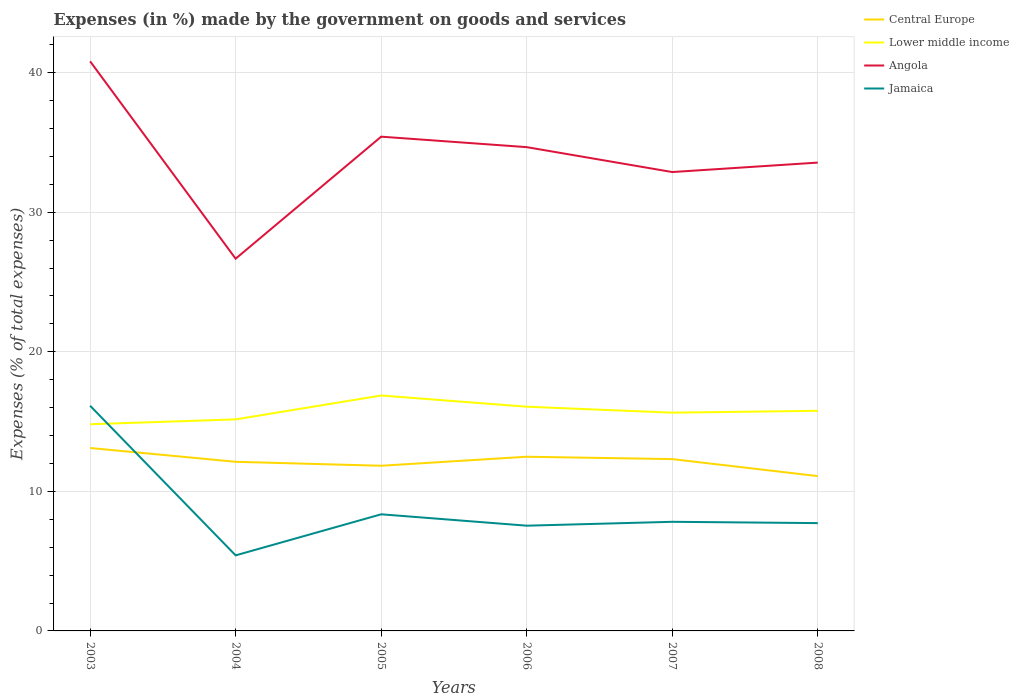Is the number of lines equal to the number of legend labels?
Provide a succinct answer. Yes. Across all years, what is the maximum percentage of expenses made by the government on goods and services in Jamaica?
Provide a succinct answer. 5.41. In which year was the percentage of expenses made by the government on goods and services in Angola maximum?
Your answer should be compact. 2004. What is the total percentage of expenses made by the government on goods and services in Central Europe in the graph?
Your answer should be compact. 1.39. What is the difference between the highest and the second highest percentage of expenses made by the government on goods and services in Lower middle income?
Ensure brevity in your answer.  2.06. How many lines are there?
Keep it short and to the point. 4. How many years are there in the graph?
Give a very brief answer. 6. Are the values on the major ticks of Y-axis written in scientific E-notation?
Make the answer very short. No. How are the legend labels stacked?
Make the answer very short. Vertical. What is the title of the graph?
Offer a very short reply. Expenses (in %) made by the government on goods and services. What is the label or title of the X-axis?
Give a very brief answer. Years. What is the label or title of the Y-axis?
Provide a short and direct response. Expenses (% of total expenses). What is the Expenses (% of total expenses) of Central Europe in 2003?
Keep it short and to the point. 13.11. What is the Expenses (% of total expenses) in Lower middle income in 2003?
Your answer should be compact. 14.81. What is the Expenses (% of total expenses) of Angola in 2003?
Ensure brevity in your answer.  40.81. What is the Expenses (% of total expenses) in Jamaica in 2003?
Offer a very short reply. 16.14. What is the Expenses (% of total expenses) of Central Europe in 2004?
Keep it short and to the point. 12.12. What is the Expenses (% of total expenses) in Lower middle income in 2004?
Provide a succinct answer. 15.16. What is the Expenses (% of total expenses) in Angola in 2004?
Offer a terse response. 26.67. What is the Expenses (% of total expenses) in Jamaica in 2004?
Keep it short and to the point. 5.41. What is the Expenses (% of total expenses) of Central Europe in 2005?
Ensure brevity in your answer.  11.83. What is the Expenses (% of total expenses) in Lower middle income in 2005?
Ensure brevity in your answer.  16.87. What is the Expenses (% of total expenses) of Angola in 2005?
Your answer should be very brief. 35.41. What is the Expenses (% of total expenses) of Jamaica in 2005?
Provide a short and direct response. 8.36. What is the Expenses (% of total expenses) in Central Europe in 2006?
Offer a very short reply. 12.48. What is the Expenses (% of total expenses) in Lower middle income in 2006?
Provide a short and direct response. 16.07. What is the Expenses (% of total expenses) in Angola in 2006?
Keep it short and to the point. 34.66. What is the Expenses (% of total expenses) of Jamaica in 2006?
Your answer should be very brief. 7.54. What is the Expenses (% of total expenses) of Central Europe in 2007?
Give a very brief answer. 12.31. What is the Expenses (% of total expenses) of Lower middle income in 2007?
Your answer should be very brief. 15.64. What is the Expenses (% of total expenses) in Angola in 2007?
Provide a short and direct response. 32.88. What is the Expenses (% of total expenses) of Jamaica in 2007?
Provide a succinct answer. 7.82. What is the Expenses (% of total expenses) of Central Europe in 2008?
Your answer should be very brief. 11.09. What is the Expenses (% of total expenses) in Lower middle income in 2008?
Make the answer very short. 15.77. What is the Expenses (% of total expenses) in Angola in 2008?
Ensure brevity in your answer.  33.56. What is the Expenses (% of total expenses) in Jamaica in 2008?
Offer a very short reply. 7.72. Across all years, what is the maximum Expenses (% of total expenses) of Central Europe?
Ensure brevity in your answer.  13.11. Across all years, what is the maximum Expenses (% of total expenses) of Lower middle income?
Give a very brief answer. 16.87. Across all years, what is the maximum Expenses (% of total expenses) of Angola?
Your answer should be very brief. 40.81. Across all years, what is the maximum Expenses (% of total expenses) of Jamaica?
Make the answer very short. 16.14. Across all years, what is the minimum Expenses (% of total expenses) in Central Europe?
Make the answer very short. 11.09. Across all years, what is the minimum Expenses (% of total expenses) in Lower middle income?
Offer a terse response. 14.81. Across all years, what is the minimum Expenses (% of total expenses) in Angola?
Your response must be concise. 26.67. Across all years, what is the minimum Expenses (% of total expenses) of Jamaica?
Make the answer very short. 5.41. What is the total Expenses (% of total expenses) in Central Europe in the graph?
Keep it short and to the point. 72.94. What is the total Expenses (% of total expenses) in Lower middle income in the graph?
Ensure brevity in your answer.  94.31. What is the total Expenses (% of total expenses) in Angola in the graph?
Provide a succinct answer. 203.99. What is the total Expenses (% of total expenses) of Jamaica in the graph?
Your response must be concise. 52.99. What is the difference between the Expenses (% of total expenses) in Lower middle income in 2003 and that in 2004?
Offer a terse response. -0.35. What is the difference between the Expenses (% of total expenses) of Angola in 2003 and that in 2004?
Your answer should be compact. 14.14. What is the difference between the Expenses (% of total expenses) in Jamaica in 2003 and that in 2004?
Your answer should be very brief. 10.72. What is the difference between the Expenses (% of total expenses) in Central Europe in 2003 and that in 2005?
Keep it short and to the point. 1.27. What is the difference between the Expenses (% of total expenses) in Lower middle income in 2003 and that in 2005?
Your answer should be compact. -2.06. What is the difference between the Expenses (% of total expenses) of Angola in 2003 and that in 2005?
Provide a succinct answer. 5.4. What is the difference between the Expenses (% of total expenses) in Jamaica in 2003 and that in 2005?
Your answer should be compact. 7.78. What is the difference between the Expenses (% of total expenses) of Central Europe in 2003 and that in 2006?
Make the answer very short. 0.63. What is the difference between the Expenses (% of total expenses) of Lower middle income in 2003 and that in 2006?
Your answer should be very brief. -1.26. What is the difference between the Expenses (% of total expenses) of Angola in 2003 and that in 2006?
Your response must be concise. 6.15. What is the difference between the Expenses (% of total expenses) of Jamaica in 2003 and that in 2006?
Your answer should be very brief. 8.59. What is the difference between the Expenses (% of total expenses) in Central Europe in 2003 and that in 2007?
Make the answer very short. 0.8. What is the difference between the Expenses (% of total expenses) in Lower middle income in 2003 and that in 2007?
Ensure brevity in your answer.  -0.83. What is the difference between the Expenses (% of total expenses) in Angola in 2003 and that in 2007?
Offer a terse response. 7.94. What is the difference between the Expenses (% of total expenses) in Jamaica in 2003 and that in 2007?
Keep it short and to the point. 8.32. What is the difference between the Expenses (% of total expenses) of Central Europe in 2003 and that in 2008?
Give a very brief answer. 2.01. What is the difference between the Expenses (% of total expenses) in Lower middle income in 2003 and that in 2008?
Provide a succinct answer. -0.96. What is the difference between the Expenses (% of total expenses) in Angola in 2003 and that in 2008?
Give a very brief answer. 7.26. What is the difference between the Expenses (% of total expenses) in Jamaica in 2003 and that in 2008?
Provide a short and direct response. 8.41. What is the difference between the Expenses (% of total expenses) in Central Europe in 2004 and that in 2005?
Provide a succinct answer. 0.28. What is the difference between the Expenses (% of total expenses) of Lower middle income in 2004 and that in 2005?
Your response must be concise. -1.71. What is the difference between the Expenses (% of total expenses) in Angola in 2004 and that in 2005?
Provide a succinct answer. -8.74. What is the difference between the Expenses (% of total expenses) in Jamaica in 2004 and that in 2005?
Your answer should be compact. -2.94. What is the difference between the Expenses (% of total expenses) in Central Europe in 2004 and that in 2006?
Provide a succinct answer. -0.36. What is the difference between the Expenses (% of total expenses) of Lower middle income in 2004 and that in 2006?
Make the answer very short. -0.91. What is the difference between the Expenses (% of total expenses) in Angola in 2004 and that in 2006?
Make the answer very short. -7.99. What is the difference between the Expenses (% of total expenses) in Jamaica in 2004 and that in 2006?
Keep it short and to the point. -2.13. What is the difference between the Expenses (% of total expenses) in Central Europe in 2004 and that in 2007?
Your answer should be compact. -0.19. What is the difference between the Expenses (% of total expenses) of Lower middle income in 2004 and that in 2007?
Provide a short and direct response. -0.48. What is the difference between the Expenses (% of total expenses) of Angola in 2004 and that in 2007?
Make the answer very short. -6.21. What is the difference between the Expenses (% of total expenses) in Jamaica in 2004 and that in 2007?
Provide a short and direct response. -2.4. What is the difference between the Expenses (% of total expenses) of Central Europe in 2004 and that in 2008?
Make the answer very short. 1.03. What is the difference between the Expenses (% of total expenses) of Lower middle income in 2004 and that in 2008?
Make the answer very short. -0.61. What is the difference between the Expenses (% of total expenses) in Angola in 2004 and that in 2008?
Provide a short and direct response. -6.88. What is the difference between the Expenses (% of total expenses) in Jamaica in 2004 and that in 2008?
Provide a succinct answer. -2.31. What is the difference between the Expenses (% of total expenses) in Central Europe in 2005 and that in 2006?
Your response must be concise. -0.65. What is the difference between the Expenses (% of total expenses) of Lower middle income in 2005 and that in 2006?
Ensure brevity in your answer.  0.8. What is the difference between the Expenses (% of total expenses) in Angola in 2005 and that in 2006?
Make the answer very short. 0.75. What is the difference between the Expenses (% of total expenses) of Jamaica in 2005 and that in 2006?
Your answer should be very brief. 0.82. What is the difference between the Expenses (% of total expenses) of Central Europe in 2005 and that in 2007?
Give a very brief answer. -0.48. What is the difference between the Expenses (% of total expenses) of Lower middle income in 2005 and that in 2007?
Provide a succinct answer. 1.23. What is the difference between the Expenses (% of total expenses) in Angola in 2005 and that in 2007?
Provide a succinct answer. 2.54. What is the difference between the Expenses (% of total expenses) in Jamaica in 2005 and that in 2007?
Keep it short and to the point. 0.54. What is the difference between the Expenses (% of total expenses) in Central Europe in 2005 and that in 2008?
Provide a short and direct response. 0.74. What is the difference between the Expenses (% of total expenses) of Lower middle income in 2005 and that in 2008?
Give a very brief answer. 1.1. What is the difference between the Expenses (% of total expenses) in Angola in 2005 and that in 2008?
Provide a short and direct response. 1.86. What is the difference between the Expenses (% of total expenses) of Jamaica in 2005 and that in 2008?
Provide a short and direct response. 0.63. What is the difference between the Expenses (% of total expenses) of Central Europe in 2006 and that in 2007?
Give a very brief answer. 0.17. What is the difference between the Expenses (% of total expenses) in Lower middle income in 2006 and that in 2007?
Offer a very short reply. 0.43. What is the difference between the Expenses (% of total expenses) in Angola in 2006 and that in 2007?
Make the answer very short. 1.78. What is the difference between the Expenses (% of total expenses) of Jamaica in 2006 and that in 2007?
Keep it short and to the point. -0.28. What is the difference between the Expenses (% of total expenses) in Central Europe in 2006 and that in 2008?
Ensure brevity in your answer.  1.39. What is the difference between the Expenses (% of total expenses) of Lower middle income in 2006 and that in 2008?
Your response must be concise. 0.29. What is the difference between the Expenses (% of total expenses) in Angola in 2006 and that in 2008?
Provide a short and direct response. 1.11. What is the difference between the Expenses (% of total expenses) in Jamaica in 2006 and that in 2008?
Offer a very short reply. -0.18. What is the difference between the Expenses (% of total expenses) in Central Europe in 2007 and that in 2008?
Make the answer very short. 1.22. What is the difference between the Expenses (% of total expenses) in Lower middle income in 2007 and that in 2008?
Ensure brevity in your answer.  -0.13. What is the difference between the Expenses (% of total expenses) of Angola in 2007 and that in 2008?
Ensure brevity in your answer.  -0.68. What is the difference between the Expenses (% of total expenses) in Jamaica in 2007 and that in 2008?
Make the answer very short. 0.09. What is the difference between the Expenses (% of total expenses) in Central Europe in 2003 and the Expenses (% of total expenses) in Lower middle income in 2004?
Ensure brevity in your answer.  -2.05. What is the difference between the Expenses (% of total expenses) in Central Europe in 2003 and the Expenses (% of total expenses) in Angola in 2004?
Provide a succinct answer. -13.56. What is the difference between the Expenses (% of total expenses) of Central Europe in 2003 and the Expenses (% of total expenses) of Jamaica in 2004?
Your answer should be very brief. 7.69. What is the difference between the Expenses (% of total expenses) of Lower middle income in 2003 and the Expenses (% of total expenses) of Angola in 2004?
Your answer should be compact. -11.86. What is the difference between the Expenses (% of total expenses) in Lower middle income in 2003 and the Expenses (% of total expenses) in Jamaica in 2004?
Provide a succinct answer. 9.39. What is the difference between the Expenses (% of total expenses) in Angola in 2003 and the Expenses (% of total expenses) in Jamaica in 2004?
Your answer should be compact. 35.4. What is the difference between the Expenses (% of total expenses) of Central Europe in 2003 and the Expenses (% of total expenses) of Lower middle income in 2005?
Ensure brevity in your answer.  -3.76. What is the difference between the Expenses (% of total expenses) in Central Europe in 2003 and the Expenses (% of total expenses) in Angola in 2005?
Give a very brief answer. -22.31. What is the difference between the Expenses (% of total expenses) in Central Europe in 2003 and the Expenses (% of total expenses) in Jamaica in 2005?
Ensure brevity in your answer.  4.75. What is the difference between the Expenses (% of total expenses) of Lower middle income in 2003 and the Expenses (% of total expenses) of Angola in 2005?
Make the answer very short. -20.6. What is the difference between the Expenses (% of total expenses) in Lower middle income in 2003 and the Expenses (% of total expenses) in Jamaica in 2005?
Provide a succinct answer. 6.45. What is the difference between the Expenses (% of total expenses) of Angola in 2003 and the Expenses (% of total expenses) of Jamaica in 2005?
Give a very brief answer. 32.46. What is the difference between the Expenses (% of total expenses) in Central Europe in 2003 and the Expenses (% of total expenses) in Lower middle income in 2006?
Ensure brevity in your answer.  -2.96. What is the difference between the Expenses (% of total expenses) of Central Europe in 2003 and the Expenses (% of total expenses) of Angola in 2006?
Provide a succinct answer. -21.56. What is the difference between the Expenses (% of total expenses) of Central Europe in 2003 and the Expenses (% of total expenses) of Jamaica in 2006?
Ensure brevity in your answer.  5.57. What is the difference between the Expenses (% of total expenses) of Lower middle income in 2003 and the Expenses (% of total expenses) of Angola in 2006?
Your answer should be compact. -19.85. What is the difference between the Expenses (% of total expenses) in Lower middle income in 2003 and the Expenses (% of total expenses) in Jamaica in 2006?
Provide a short and direct response. 7.27. What is the difference between the Expenses (% of total expenses) of Angola in 2003 and the Expenses (% of total expenses) of Jamaica in 2006?
Your answer should be very brief. 33.27. What is the difference between the Expenses (% of total expenses) in Central Europe in 2003 and the Expenses (% of total expenses) in Lower middle income in 2007?
Make the answer very short. -2.53. What is the difference between the Expenses (% of total expenses) in Central Europe in 2003 and the Expenses (% of total expenses) in Angola in 2007?
Offer a very short reply. -19.77. What is the difference between the Expenses (% of total expenses) of Central Europe in 2003 and the Expenses (% of total expenses) of Jamaica in 2007?
Your response must be concise. 5.29. What is the difference between the Expenses (% of total expenses) in Lower middle income in 2003 and the Expenses (% of total expenses) in Angola in 2007?
Provide a succinct answer. -18.07. What is the difference between the Expenses (% of total expenses) of Lower middle income in 2003 and the Expenses (% of total expenses) of Jamaica in 2007?
Your answer should be compact. 6.99. What is the difference between the Expenses (% of total expenses) of Angola in 2003 and the Expenses (% of total expenses) of Jamaica in 2007?
Offer a terse response. 33. What is the difference between the Expenses (% of total expenses) of Central Europe in 2003 and the Expenses (% of total expenses) of Lower middle income in 2008?
Ensure brevity in your answer.  -2.66. What is the difference between the Expenses (% of total expenses) of Central Europe in 2003 and the Expenses (% of total expenses) of Angola in 2008?
Make the answer very short. -20.45. What is the difference between the Expenses (% of total expenses) in Central Europe in 2003 and the Expenses (% of total expenses) in Jamaica in 2008?
Ensure brevity in your answer.  5.38. What is the difference between the Expenses (% of total expenses) of Lower middle income in 2003 and the Expenses (% of total expenses) of Angola in 2008?
Offer a terse response. -18.75. What is the difference between the Expenses (% of total expenses) of Lower middle income in 2003 and the Expenses (% of total expenses) of Jamaica in 2008?
Keep it short and to the point. 7.08. What is the difference between the Expenses (% of total expenses) in Angola in 2003 and the Expenses (% of total expenses) in Jamaica in 2008?
Your answer should be very brief. 33.09. What is the difference between the Expenses (% of total expenses) in Central Europe in 2004 and the Expenses (% of total expenses) in Lower middle income in 2005?
Provide a succinct answer. -4.75. What is the difference between the Expenses (% of total expenses) in Central Europe in 2004 and the Expenses (% of total expenses) in Angola in 2005?
Provide a short and direct response. -23.3. What is the difference between the Expenses (% of total expenses) in Central Europe in 2004 and the Expenses (% of total expenses) in Jamaica in 2005?
Offer a very short reply. 3.76. What is the difference between the Expenses (% of total expenses) in Lower middle income in 2004 and the Expenses (% of total expenses) in Angola in 2005?
Make the answer very short. -20.26. What is the difference between the Expenses (% of total expenses) of Lower middle income in 2004 and the Expenses (% of total expenses) of Jamaica in 2005?
Provide a short and direct response. 6.8. What is the difference between the Expenses (% of total expenses) in Angola in 2004 and the Expenses (% of total expenses) in Jamaica in 2005?
Provide a succinct answer. 18.31. What is the difference between the Expenses (% of total expenses) of Central Europe in 2004 and the Expenses (% of total expenses) of Lower middle income in 2006?
Your response must be concise. -3.95. What is the difference between the Expenses (% of total expenses) in Central Europe in 2004 and the Expenses (% of total expenses) in Angola in 2006?
Keep it short and to the point. -22.54. What is the difference between the Expenses (% of total expenses) of Central Europe in 2004 and the Expenses (% of total expenses) of Jamaica in 2006?
Your answer should be compact. 4.58. What is the difference between the Expenses (% of total expenses) of Lower middle income in 2004 and the Expenses (% of total expenses) of Angola in 2006?
Provide a succinct answer. -19.51. What is the difference between the Expenses (% of total expenses) in Lower middle income in 2004 and the Expenses (% of total expenses) in Jamaica in 2006?
Offer a very short reply. 7.62. What is the difference between the Expenses (% of total expenses) in Angola in 2004 and the Expenses (% of total expenses) in Jamaica in 2006?
Offer a terse response. 19.13. What is the difference between the Expenses (% of total expenses) of Central Europe in 2004 and the Expenses (% of total expenses) of Lower middle income in 2007?
Your answer should be compact. -3.52. What is the difference between the Expenses (% of total expenses) of Central Europe in 2004 and the Expenses (% of total expenses) of Angola in 2007?
Offer a terse response. -20.76. What is the difference between the Expenses (% of total expenses) in Central Europe in 2004 and the Expenses (% of total expenses) in Jamaica in 2007?
Give a very brief answer. 4.3. What is the difference between the Expenses (% of total expenses) of Lower middle income in 2004 and the Expenses (% of total expenses) of Angola in 2007?
Make the answer very short. -17.72. What is the difference between the Expenses (% of total expenses) in Lower middle income in 2004 and the Expenses (% of total expenses) in Jamaica in 2007?
Offer a terse response. 7.34. What is the difference between the Expenses (% of total expenses) in Angola in 2004 and the Expenses (% of total expenses) in Jamaica in 2007?
Give a very brief answer. 18.85. What is the difference between the Expenses (% of total expenses) in Central Europe in 2004 and the Expenses (% of total expenses) in Lower middle income in 2008?
Give a very brief answer. -3.65. What is the difference between the Expenses (% of total expenses) in Central Europe in 2004 and the Expenses (% of total expenses) in Angola in 2008?
Offer a very short reply. -21.44. What is the difference between the Expenses (% of total expenses) of Central Europe in 2004 and the Expenses (% of total expenses) of Jamaica in 2008?
Your answer should be very brief. 4.39. What is the difference between the Expenses (% of total expenses) of Lower middle income in 2004 and the Expenses (% of total expenses) of Angola in 2008?
Ensure brevity in your answer.  -18.4. What is the difference between the Expenses (% of total expenses) in Lower middle income in 2004 and the Expenses (% of total expenses) in Jamaica in 2008?
Make the answer very short. 7.43. What is the difference between the Expenses (% of total expenses) of Angola in 2004 and the Expenses (% of total expenses) of Jamaica in 2008?
Your response must be concise. 18.95. What is the difference between the Expenses (% of total expenses) of Central Europe in 2005 and the Expenses (% of total expenses) of Lower middle income in 2006?
Keep it short and to the point. -4.23. What is the difference between the Expenses (% of total expenses) of Central Europe in 2005 and the Expenses (% of total expenses) of Angola in 2006?
Provide a short and direct response. -22.83. What is the difference between the Expenses (% of total expenses) in Central Europe in 2005 and the Expenses (% of total expenses) in Jamaica in 2006?
Provide a succinct answer. 4.29. What is the difference between the Expenses (% of total expenses) of Lower middle income in 2005 and the Expenses (% of total expenses) of Angola in 2006?
Offer a very short reply. -17.79. What is the difference between the Expenses (% of total expenses) of Lower middle income in 2005 and the Expenses (% of total expenses) of Jamaica in 2006?
Your answer should be very brief. 9.33. What is the difference between the Expenses (% of total expenses) of Angola in 2005 and the Expenses (% of total expenses) of Jamaica in 2006?
Offer a very short reply. 27.87. What is the difference between the Expenses (% of total expenses) in Central Europe in 2005 and the Expenses (% of total expenses) in Lower middle income in 2007?
Provide a succinct answer. -3.8. What is the difference between the Expenses (% of total expenses) in Central Europe in 2005 and the Expenses (% of total expenses) in Angola in 2007?
Offer a terse response. -21.04. What is the difference between the Expenses (% of total expenses) of Central Europe in 2005 and the Expenses (% of total expenses) of Jamaica in 2007?
Keep it short and to the point. 4.02. What is the difference between the Expenses (% of total expenses) of Lower middle income in 2005 and the Expenses (% of total expenses) of Angola in 2007?
Ensure brevity in your answer.  -16.01. What is the difference between the Expenses (% of total expenses) in Lower middle income in 2005 and the Expenses (% of total expenses) in Jamaica in 2007?
Offer a terse response. 9.05. What is the difference between the Expenses (% of total expenses) of Angola in 2005 and the Expenses (% of total expenses) of Jamaica in 2007?
Your answer should be very brief. 27.6. What is the difference between the Expenses (% of total expenses) of Central Europe in 2005 and the Expenses (% of total expenses) of Lower middle income in 2008?
Give a very brief answer. -3.94. What is the difference between the Expenses (% of total expenses) in Central Europe in 2005 and the Expenses (% of total expenses) in Angola in 2008?
Keep it short and to the point. -21.72. What is the difference between the Expenses (% of total expenses) in Central Europe in 2005 and the Expenses (% of total expenses) in Jamaica in 2008?
Provide a succinct answer. 4.11. What is the difference between the Expenses (% of total expenses) of Lower middle income in 2005 and the Expenses (% of total expenses) of Angola in 2008?
Give a very brief answer. -16.69. What is the difference between the Expenses (% of total expenses) of Lower middle income in 2005 and the Expenses (% of total expenses) of Jamaica in 2008?
Provide a short and direct response. 9.14. What is the difference between the Expenses (% of total expenses) in Angola in 2005 and the Expenses (% of total expenses) in Jamaica in 2008?
Your answer should be compact. 27.69. What is the difference between the Expenses (% of total expenses) in Central Europe in 2006 and the Expenses (% of total expenses) in Lower middle income in 2007?
Offer a very short reply. -3.16. What is the difference between the Expenses (% of total expenses) of Central Europe in 2006 and the Expenses (% of total expenses) of Angola in 2007?
Ensure brevity in your answer.  -20.4. What is the difference between the Expenses (% of total expenses) in Central Europe in 2006 and the Expenses (% of total expenses) in Jamaica in 2007?
Keep it short and to the point. 4.66. What is the difference between the Expenses (% of total expenses) in Lower middle income in 2006 and the Expenses (% of total expenses) in Angola in 2007?
Keep it short and to the point. -16.81. What is the difference between the Expenses (% of total expenses) of Lower middle income in 2006 and the Expenses (% of total expenses) of Jamaica in 2007?
Ensure brevity in your answer.  8.25. What is the difference between the Expenses (% of total expenses) in Angola in 2006 and the Expenses (% of total expenses) in Jamaica in 2007?
Offer a terse response. 26.84. What is the difference between the Expenses (% of total expenses) in Central Europe in 2006 and the Expenses (% of total expenses) in Lower middle income in 2008?
Your response must be concise. -3.29. What is the difference between the Expenses (% of total expenses) in Central Europe in 2006 and the Expenses (% of total expenses) in Angola in 2008?
Offer a very short reply. -21.08. What is the difference between the Expenses (% of total expenses) of Central Europe in 2006 and the Expenses (% of total expenses) of Jamaica in 2008?
Offer a terse response. 4.76. What is the difference between the Expenses (% of total expenses) of Lower middle income in 2006 and the Expenses (% of total expenses) of Angola in 2008?
Make the answer very short. -17.49. What is the difference between the Expenses (% of total expenses) of Lower middle income in 2006 and the Expenses (% of total expenses) of Jamaica in 2008?
Give a very brief answer. 8.34. What is the difference between the Expenses (% of total expenses) in Angola in 2006 and the Expenses (% of total expenses) in Jamaica in 2008?
Provide a succinct answer. 26.94. What is the difference between the Expenses (% of total expenses) in Central Europe in 2007 and the Expenses (% of total expenses) in Lower middle income in 2008?
Give a very brief answer. -3.46. What is the difference between the Expenses (% of total expenses) in Central Europe in 2007 and the Expenses (% of total expenses) in Angola in 2008?
Offer a very short reply. -21.24. What is the difference between the Expenses (% of total expenses) in Central Europe in 2007 and the Expenses (% of total expenses) in Jamaica in 2008?
Provide a succinct answer. 4.59. What is the difference between the Expenses (% of total expenses) of Lower middle income in 2007 and the Expenses (% of total expenses) of Angola in 2008?
Your answer should be very brief. -17.92. What is the difference between the Expenses (% of total expenses) of Lower middle income in 2007 and the Expenses (% of total expenses) of Jamaica in 2008?
Ensure brevity in your answer.  7.91. What is the difference between the Expenses (% of total expenses) in Angola in 2007 and the Expenses (% of total expenses) in Jamaica in 2008?
Your answer should be compact. 25.15. What is the average Expenses (% of total expenses) of Central Europe per year?
Provide a short and direct response. 12.16. What is the average Expenses (% of total expenses) in Lower middle income per year?
Offer a terse response. 15.72. What is the average Expenses (% of total expenses) of Angola per year?
Provide a short and direct response. 34. What is the average Expenses (% of total expenses) in Jamaica per year?
Ensure brevity in your answer.  8.83. In the year 2003, what is the difference between the Expenses (% of total expenses) of Central Europe and Expenses (% of total expenses) of Lower middle income?
Keep it short and to the point. -1.7. In the year 2003, what is the difference between the Expenses (% of total expenses) of Central Europe and Expenses (% of total expenses) of Angola?
Provide a succinct answer. -27.71. In the year 2003, what is the difference between the Expenses (% of total expenses) of Central Europe and Expenses (% of total expenses) of Jamaica?
Offer a very short reply. -3.03. In the year 2003, what is the difference between the Expenses (% of total expenses) of Lower middle income and Expenses (% of total expenses) of Angola?
Make the answer very short. -26.01. In the year 2003, what is the difference between the Expenses (% of total expenses) in Lower middle income and Expenses (% of total expenses) in Jamaica?
Your response must be concise. -1.33. In the year 2003, what is the difference between the Expenses (% of total expenses) of Angola and Expenses (% of total expenses) of Jamaica?
Your response must be concise. 24.68. In the year 2004, what is the difference between the Expenses (% of total expenses) in Central Europe and Expenses (% of total expenses) in Lower middle income?
Your answer should be compact. -3.04. In the year 2004, what is the difference between the Expenses (% of total expenses) of Central Europe and Expenses (% of total expenses) of Angola?
Ensure brevity in your answer.  -14.55. In the year 2004, what is the difference between the Expenses (% of total expenses) in Central Europe and Expenses (% of total expenses) in Jamaica?
Keep it short and to the point. 6.7. In the year 2004, what is the difference between the Expenses (% of total expenses) in Lower middle income and Expenses (% of total expenses) in Angola?
Offer a very short reply. -11.51. In the year 2004, what is the difference between the Expenses (% of total expenses) in Lower middle income and Expenses (% of total expenses) in Jamaica?
Offer a terse response. 9.74. In the year 2004, what is the difference between the Expenses (% of total expenses) in Angola and Expenses (% of total expenses) in Jamaica?
Keep it short and to the point. 21.26. In the year 2005, what is the difference between the Expenses (% of total expenses) of Central Europe and Expenses (% of total expenses) of Lower middle income?
Provide a short and direct response. -5.03. In the year 2005, what is the difference between the Expenses (% of total expenses) of Central Europe and Expenses (% of total expenses) of Angola?
Your answer should be compact. -23.58. In the year 2005, what is the difference between the Expenses (% of total expenses) of Central Europe and Expenses (% of total expenses) of Jamaica?
Offer a very short reply. 3.48. In the year 2005, what is the difference between the Expenses (% of total expenses) of Lower middle income and Expenses (% of total expenses) of Angola?
Give a very brief answer. -18.55. In the year 2005, what is the difference between the Expenses (% of total expenses) of Lower middle income and Expenses (% of total expenses) of Jamaica?
Give a very brief answer. 8.51. In the year 2005, what is the difference between the Expenses (% of total expenses) in Angola and Expenses (% of total expenses) in Jamaica?
Your answer should be compact. 27.06. In the year 2006, what is the difference between the Expenses (% of total expenses) in Central Europe and Expenses (% of total expenses) in Lower middle income?
Your answer should be very brief. -3.59. In the year 2006, what is the difference between the Expenses (% of total expenses) in Central Europe and Expenses (% of total expenses) in Angola?
Provide a succinct answer. -22.18. In the year 2006, what is the difference between the Expenses (% of total expenses) in Central Europe and Expenses (% of total expenses) in Jamaica?
Offer a terse response. 4.94. In the year 2006, what is the difference between the Expenses (% of total expenses) in Lower middle income and Expenses (% of total expenses) in Angola?
Give a very brief answer. -18.6. In the year 2006, what is the difference between the Expenses (% of total expenses) of Lower middle income and Expenses (% of total expenses) of Jamaica?
Provide a short and direct response. 8.52. In the year 2006, what is the difference between the Expenses (% of total expenses) in Angola and Expenses (% of total expenses) in Jamaica?
Your response must be concise. 27.12. In the year 2007, what is the difference between the Expenses (% of total expenses) of Central Europe and Expenses (% of total expenses) of Lower middle income?
Your answer should be very brief. -3.33. In the year 2007, what is the difference between the Expenses (% of total expenses) in Central Europe and Expenses (% of total expenses) in Angola?
Keep it short and to the point. -20.57. In the year 2007, what is the difference between the Expenses (% of total expenses) in Central Europe and Expenses (% of total expenses) in Jamaica?
Ensure brevity in your answer.  4.49. In the year 2007, what is the difference between the Expenses (% of total expenses) of Lower middle income and Expenses (% of total expenses) of Angola?
Your answer should be very brief. -17.24. In the year 2007, what is the difference between the Expenses (% of total expenses) in Lower middle income and Expenses (% of total expenses) in Jamaica?
Offer a very short reply. 7.82. In the year 2007, what is the difference between the Expenses (% of total expenses) in Angola and Expenses (% of total expenses) in Jamaica?
Give a very brief answer. 25.06. In the year 2008, what is the difference between the Expenses (% of total expenses) in Central Europe and Expenses (% of total expenses) in Lower middle income?
Make the answer very short. -4.68. In the year 2008, what is the difference between the Expenses (% of total expenses) in Central Europe and Expenses (% of total expenses) in Angola?
Ensure brevity in your answer.  -22.46. In the year 2008, what is the difference between the Expenses (% of total expenses) in Central Europe and Expenses (% of total expenses) in Jamaica?
Provide a succinct answer. 3.37. In the year 2008, what is the difference between the Expenses (% of total expenses) of Lower middle income and Expenses (% of total expenses) of Angola?
Your response must be concise. -17.79. In the year 2008, what is the difference between the Expenses (% of total expenses) of Lower middle income and Expenses (% of total expenses) of Jamaica?
Provide a short and direct response. 8.05. In the year 2008, what is the difference between the Expenses (% of total expenses) in Angola and Expenses (% of total expenses) in Jamaica?
Offer a very short reply. 25.83. What is the ratio of the Expenses (% of total expenses) of Central Europe in 2003 to that in 2004?
Provide a succinct answer. 1.08. What is the ratio of the Expenses (% of total expenses) of Lower middle income in 2003 to that in 2004?
Give a very brief answer. 0.98. What is the ratio of the Expenses (% of total expenses) of Angola in 2003 to that in 2004?
Provide a succinct answer. 1.53. What is the ratio of the Expenses (% of total expenses) of Jamaica in 2003 to that in 2004?
Offer a terse response. 2.98. What is the ratio of the Expenses (% of total expenses) in Central Europe in 2003 to that in 2005?
Make the answer very short. 1.11. What is the ratio of the Expenses (% of total expenses) in Lower middle income in 2003 to that in 2005?
Offer a very short reply. 0.88. What is the ratio of the Expenses (% of total expenses) in Angola in 2003 to that in 2005?
Your response must be concise. 1.15. What is the ratio of the Expenses (% of total expenses) in Jamaica in 2003 to that in 2005?
Keep it short and to the point. 1.93. What is the ratio of the Expenses (% of total expenses) of Central Europe in 2003 to that in 2006?
Provide a short and direct response. 1.05. What is the ratio of the Expenses (% of total expenses) of Lower middle income in 2003 to that in 2006?
Your response must be concise. 0.92. What is the ratio of the Expenses (% of total expenses) of Angola in 2003 to that in 2006?
Ensure brevity in your answer.  1.18. What is the ratio of the Expenses (% of total expenses) in Jamaica in 2003 to that in 2006?
Offer a very short reply. 2.14. What is the ratio of the Expenses (% of total expenses) of Central Europe in 2003 to that in 2007?
Keep it short and to the point. 1.06. What is the ratio of the Expenses (% of total expenses) of Lower middle income in 2003 to that in 2007?
Provide a short and direct response. 0.95. What is the ratio of the Expenses (% of total expenses) of Angola in 2003 to that in 2007?
Make the answer very short. 1.24. What is the ratio of the Expenses (% of total expenses) in Jamaica in 2003 to that in 2007?
Offer a terse response. 2.06. What is the ratio of the Expenses (% of total expenses) of Central Europe in 2003 to that in 2008?
Your response must be concise. 1.18. What is the ratio of the Expenses (% of total expenses) in Lower middle income in 2003 to that in 2008?
Give a very brief answer. 0.94. What is the ratio of the Expenses (% of total expenses) in Angola in 2003 to that in 2008?
Your response must be concise. 1.22. What is the ratio of the Expenses (% of total expenses) in Jamaica in 2003 to that in 2008?
Offer a terse response. 2.09. What is the ratio of the Expenses (% of total expenses) in Central Europe in 2004 to that in 2005?
Your response must be concise. 1.02. What is the ratio of the Expenses (% of total expenses) of Lower middle income in 2004 to that in 2005?
Provide a short and direct response. 0.9. What is the ratio of the Expenses (% of total expenses) of Angola in 2004 to that in 2005?
Provide a succinct answer. 0.75. What is the ratio of the Expenses (% of total expenses) of Jamaica in 2004 to that in 2005?
Give a very brief answer. 0.65. What is the ratio of the Expenses (% of total expenses) in Lower middle income in 2004 to that in 2006?
Make the answer very short. 0.94. What is the ratio of the Expenses (% of total expenses) in Angola in 2004 to that in 2006?
Keep it short and to the point. 0.77. What is the ratio of the Expenses (% of total expenses) in Jamaica in 2004 to that in 2006?
Provide a short and direct response. 0.72. What is the ratio of the Expenses (% of total expenses) of Central Europe in 2004 to that in 2007?
Your answer should be very brief. 0.98. What is the ratio of the Expenses (% of total expenses) in Lower middle income in 2004 to that in 2007?
Offer a very short reply. 0.97. What is the ratio of the Expenses (% of total expenses) of Angola in 2004 to that in 2007?
Provide a short and direct response. 0.81. What is the ratio of the Expenses (% of total expenses) in Jamaica in 2004 to that in 2007?
Provide a succinct answer. 0.69. What is the ratio of the Expenses (% of total expenses) of Central Europe in 2004 to that in 2008?
Offer a terse response. 1.09. What is the ratio of the Expenses (% of total expenses) of Lower middle income in 2004 to that in 2008?
Your answer should be compact. 0.96. What is the ratio of the Expenses (% of total expenses) of Angola in 2004 to that in 2008?
Ensure brevity in your answer.  0.79. What is the ratio of the Expenses (% of total expenses) in Jamaica in 2004 to that in 2008?
Keep it short and to the point. 0.7. What is the ratio of the Expenses (% of total expenses) in Central Europe in 2005 to that in 2006?
Keep it short and to the point. 0.95. What is the ratio of the Expenses (% of total expenses) of Angola in 2005 to that in 2006?
Your answer should be very brief. 1.02. What is the ratio of the Expenses (% of total expenses) in Jamaica in 2005 to that in 2006?
Ensure brevity in your answer.  1.11. What is the ratio of the Expenses (% of total expenses) of Central Europe in 2005 to that in 2007?
Make the answer very short. 0.96. What is the ratio of the Expenses (% of total expenses) in Lower middle income in 2005 to that in 2007?
Offer a very short reply. 1.08. What is the ratio of the Expenses (% of total expenses) of Angola in 2005 to that in 2007?
Your answer should be compact. 1.08. What is the ratio of the Expenses (% of total expenses) of Jamaica in 2005 to that in 2007?
Give a very brief answer. 1.07. What is the ratio of the Expenses (% of total expenses) in Central Europe in 2005 to that in 2008?
Keep it short and to the point. 1.07. What is the ratio of the Expenses (% of total expenses) of Lower middle income in 2005 to that in 2008?
Provide a short and direct response. 1.07. What is the ratio of the Expenses (% of total expenses) in Angola in 2005 to that in 2008?
Your answer should be compact. 1.06. What is the ratio of the Expenses (% of total expenses) in Jamaica in 2005 to that in 2008?
Make the answer very short. 1.08. What is the ratio of the Expenses (% of total expenses) of Central Europe in 2006 to that in 2007?
Provide a succinct answer. 1.01. What is the ratio of the Expenses (% of total expenses) of Lower middle income in 2006 to that in 2007?
Your answer should be compact. 1.03. What is the ratio of the Expenses (% of total expenses) in Angola in 2006 to that in 2007?
Provide a succinct answer. 1.05. What is the ratio of the Expenses (% of total expenses) in Jamaica in 2006 to that in 2007?
Your response must be concise. 0.96. What is the ratio of the Expenses (% of total expenses) of Central Europe in 2006 to that in 2008?
Offer a terse response. 1.13. What is the ratio of the Expenses (% of total expenses) in Lower middle income in 2006 to that in 2008?
Your answer should be compact. 1.02. What is the ratio of the Expenses (% of total expenses) in Angola in 2006 to that in 2008?
Make the answer very short. 1.03. What is the ratio of the Expenses (% of total expenses) of Jamaica in 2006 to that in 2008?
Provide a succinct answer. 0.98. What is the ratio of the Expenses (% of total expenses) of Central Europe in 2007 to that in 2008?
Provide a succinct answer. 1.11. What is the ratio of the Expenses (% of total expenses) in Angola in 2007 to that in 2008?
Offer a terse response. 0.98. What is the ratio of the Expenses (% of total expenses) of Jamaica in 2007 to that in 2008?
Your answer should be very brief. 1.01. What is the difference between the highest and the second highest Expenses (% of total expenses) in Central Europe?
Ensure brevity in your answer.  0.63. What is the difference between the highest and the second highest Expenses (% of total expenses) of Lower middle income?
Give a very brief answer. 0.8. What is the difference between the highest and the second highest Expenses (% of total expenses) of Angola?
Keep it short and to the point. 5.4. What is the difference between the highest and the second highest Expenses (% of total expenses) in Jamaica?
Keep it short and to the point. 7.78. What is the difference between the highest and the lowest Expenses (% of total expenses) of Central Europe?
Your answer should be compact. 2.01. What is the difference between the highest and the lowest Expenses (% of total expenses) of Lower middle income?
Provide a succinct answer. 2.06. What is the difference between the highest and the lowest Expenses (% of total expenses) of Angola?
Ensure brevity in your answer.  14.14. What is the difference between the highest and the lowest Expenses (% of total expenses) in Jamaica?
Provide a short and direct response. 10.72. 